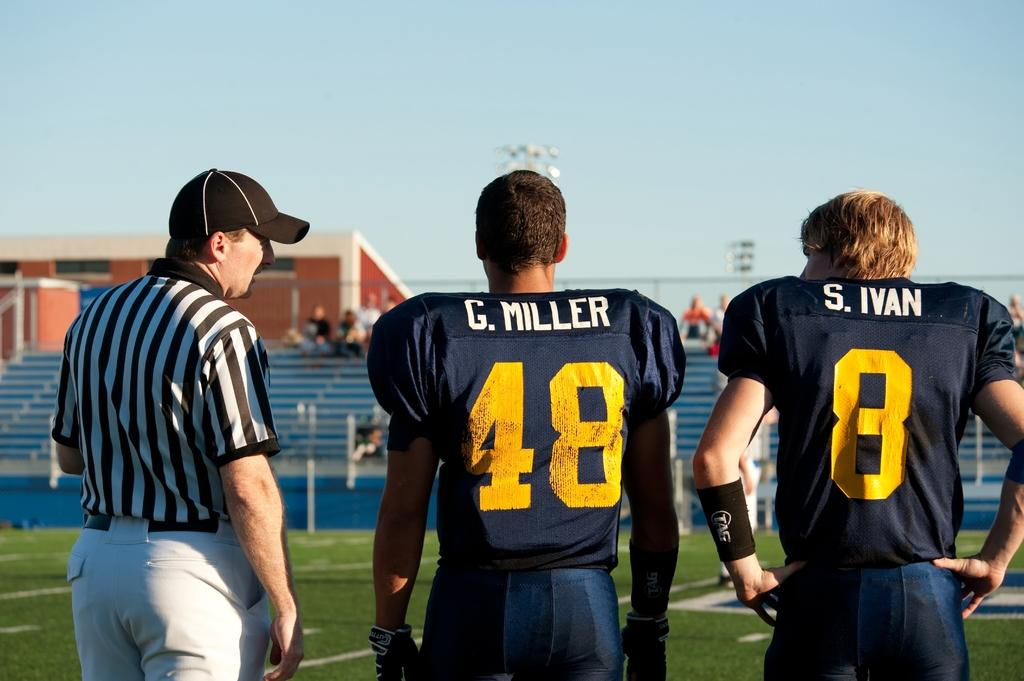<image>
Provide a brief description of the given image. Man wearing number 48 standing next to another man wearing number 8 . 